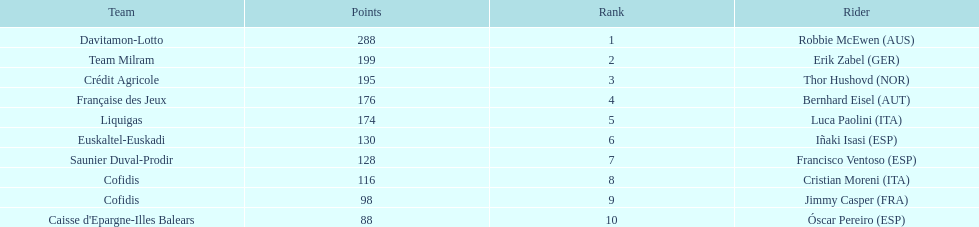How many points did robbie mcewen and cristian moreni score together? 404. 